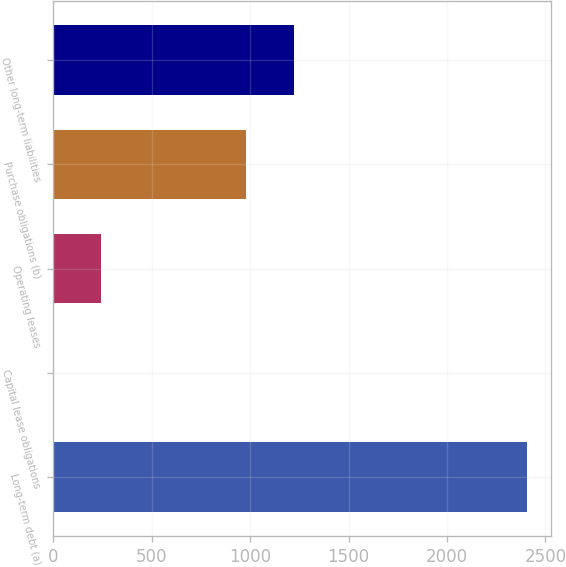Convert chart. <chart><loc_0><loc_0><loc_500><loc_500><bar_chart><fcel>Long-term debt (a)<fcel>Capital lease obligations<fcel>Operating leases<fcel>Purchase obligations (b)<fcel>Other long-term liabilities<nl><fcel>2407<fcel>1<fcel>241.6<fcel>981<fcel>1221.6<nl></chart> 